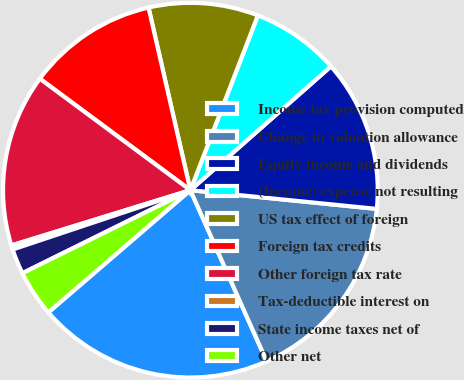Convert chart to OTSL. <chart><loc_0><loc_0><loc_500><loc_500><pie_chart><fcel>Income tax provision computed<fcel>Change in valuation allowance<fcel>Equity income and dividends<fcel>(Income) expense not resulting<fcel>US tax effect of foreign<fcel>Foreign tax credits<fcel>Other foreign tax rate<fcel>Tax-deductible interest on<fcel>State income taxes net of<fcel>Other net<nl><fcel>20.37%<fcel>16.73%<fcel>13.09%<fcel>7.64%<fcel>9.45%<fcel>11.27%<fcel>14.91%<fcel>0.36%<fcel>2.18%<fcel>4.0%<nl></chart> 